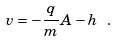Convert formula to latex. <formula><loc_0><loc_0><loc_500><loc_500>v = - \frac { q } { m } A - h \text { } .</formula> 